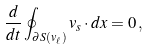Convert formula to latex. <formula><loc_0><loc_0><loc_500><loc_500>\frac { d } { d t } \oint _ { \partial S ( v _ { \ell } ) } v _ { s } \cdot d x = 0 \, ,</formula> 